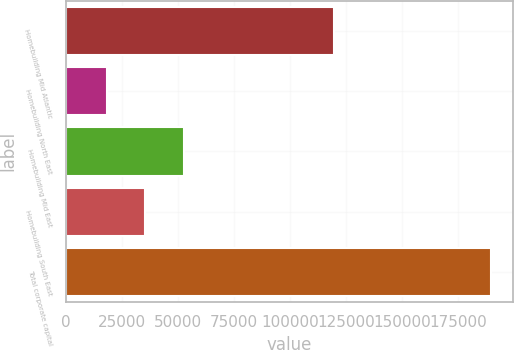<chart> <loc_0><loc_0><loc_500><loc_500><bar_chart><fcel>Homebuilding Mid Atlantic<fcel>Homebuilding North East<fcel>Homebuilding Mid East<fcel>Homebuilding South East<fcel>Total corporate capital<nl><fcel>119758<fcel>18132<fcel>52504<fcel>35318<fcel>189992<nl></chart> 